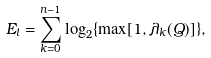Convert formula to latex. <formula><loc_0><loc_0><loc_500><loc_500>E _ { l } = \sum _ { k = 0 } ^ { n - 1 } \log _ { 2 } \{ \max [ 1 , \lambda _ { k } ( Q ) ] \} ,</formula> 